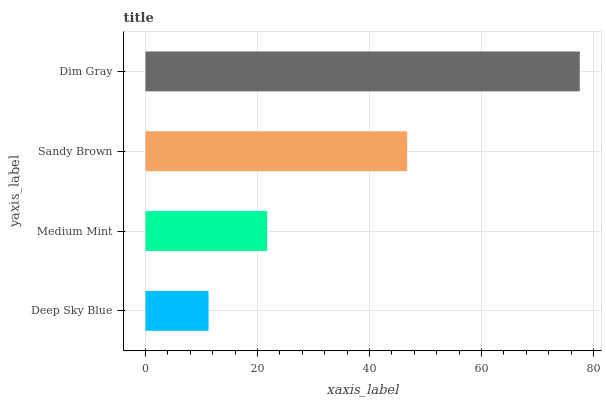Is Deep Sky Blue the minimum?
Answer yes or no. Yes. Is Dim Gray the maximum?
Answer yes or no. Yes. Is Medium Mint the minimum?
Answer yes or no. No. Is Medium Mint the maximum?
Answer yes or no. No. Is Medium Mint greater than Deep Sky Blue?
Answer yes or no. Yes. Is Deep Sky Blue less than Medium Mint?
Answer yes or no. Yes. Is Deep Sky Blue greater than Medium Mint?
Answer yes or no. No. Is Medium Mint less than Deep Sky Blue?
Answer yes or no. No. Is Sandy Brown the high median?
Answer yes or no. Yes. Is Medium Mint the low median?
Answer yes or no. Yes. Is Dim Gray the high median?
Answer yes or no. No. Is Deep Sky Blue the low median?
Answer yes or no. No. 